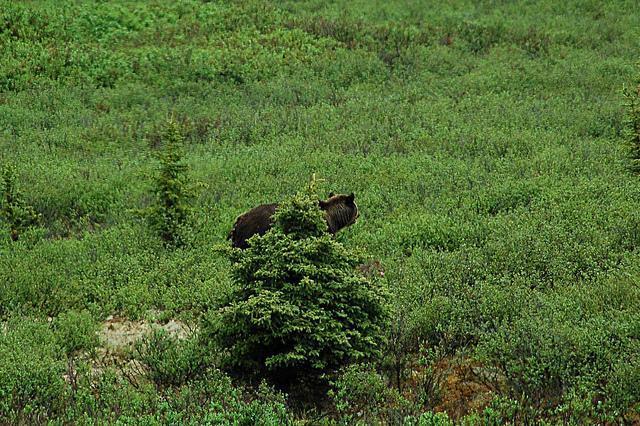How many different colors of leaves are there?
Give a very brief answer. 1. 